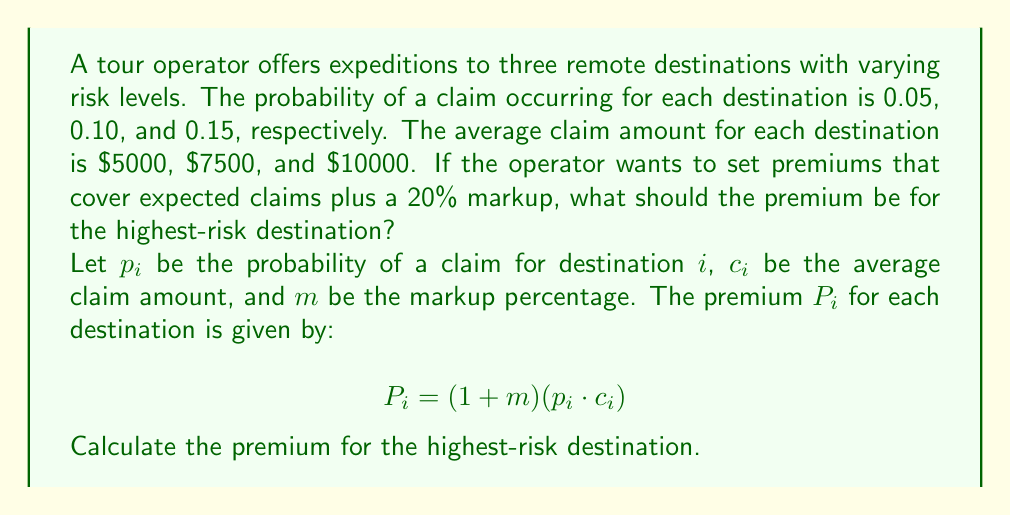Provide a solution to this math problem. To solve this inverse problem, we need to:

1. Identify the highest-risk destination
2. Use the given formula to calculate the premium

Step 1: Identify the highest-risk destination
The probabilities of claims are 0.05, 0.10, and 0.15. The highest risk is 0.15, corresponding to the third destination.

Step 2: Calculate the premium using the formula
For the highest-risk destination:
$p_3 = 0.15$ (probability of claim)
$c_3 = 10000$ (average claim amount)
$m = 0.20$ (20% markup)

Plugging these values into the formula:

$$\begin{align}
P_3 &= (1 + m)(p_3 \cdot c_3) \\
&= (1 + 0.20)(0.15 \cdot 10000) \\
&= 1.20 \cdot 1500 \\
&= 1800
\end{align}$$

Therefore, the premium for the highest-risk destination should be $1800.
Answer: $1800 